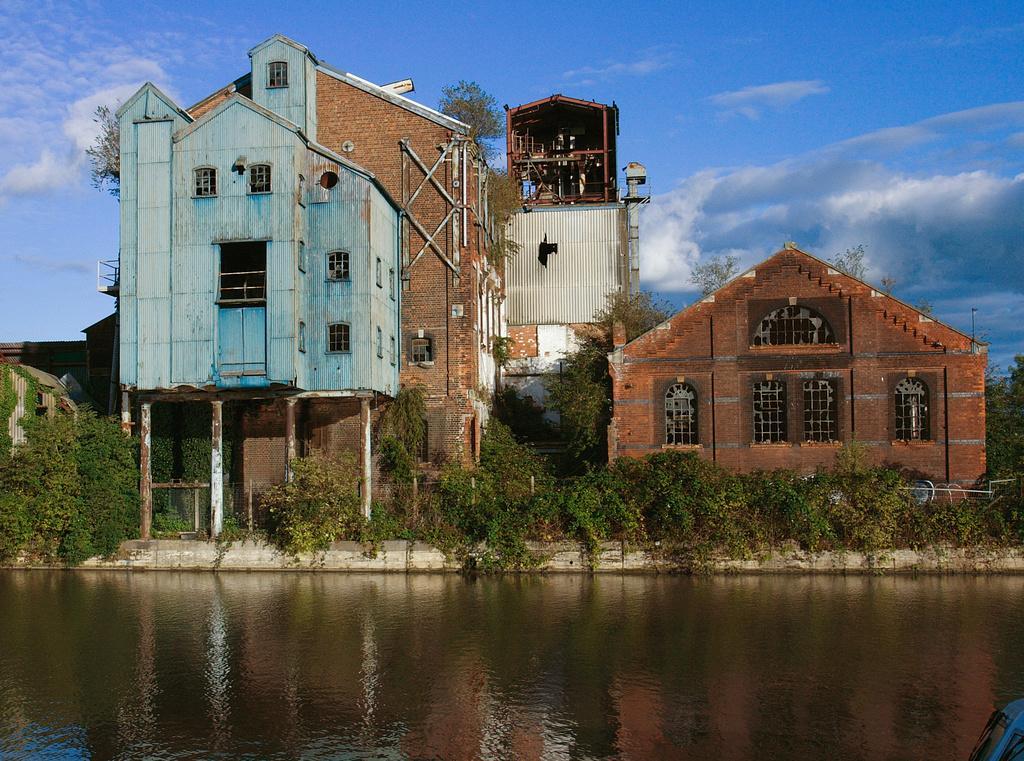Describe this image in one or two sentences. In the foreground of the picture there is a water body. In the middle of the picture there are plants, trees and buildings. In the background there is sky. 